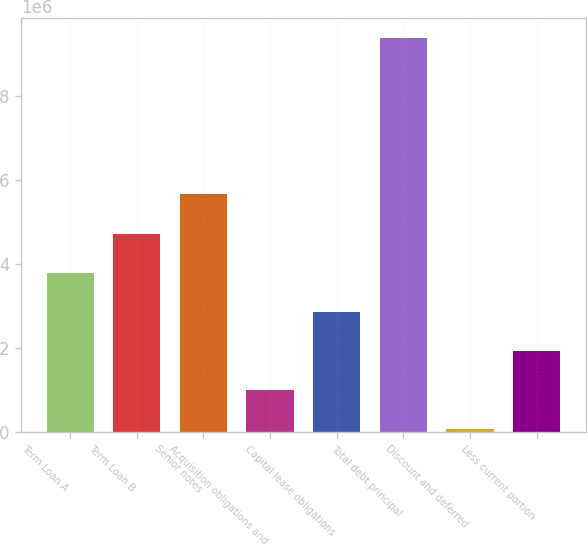Convert chart. <chart><loc_0><loc_0><loc_500><loc_500><bar_chart><fcel>Term Loan A<fcel>Term Loan B<fcel>Senior notes<fcel>Acquisition obligations and<fcel>Capital lease obligations<fcel>Total debt principal<fcel>Discount and deferred<fcel>Less current portion<nl><fcel>3.79844e+06<fcel>4.73207e+06<fcel>5.66569e+06<fcel>997574<fcel>2.86482e+06<fcel>9.40018e+06<fcel>63951<fcel>1.9312e+06<nl></chart> 